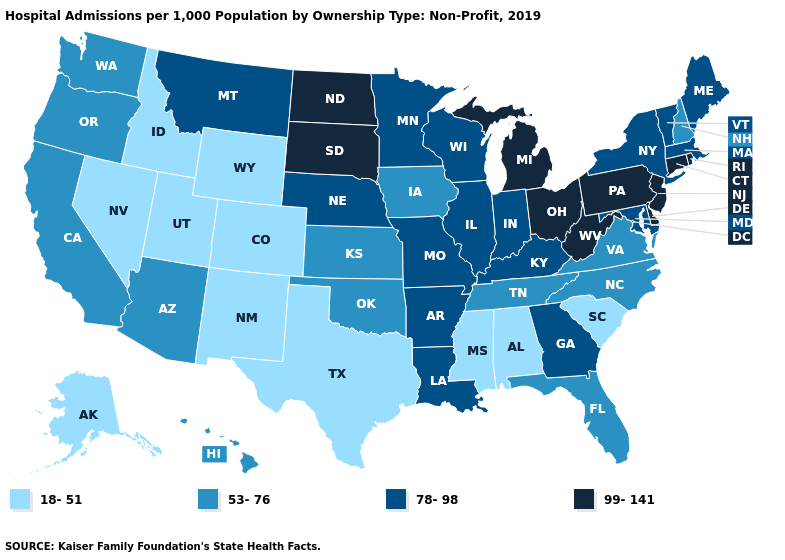What is the value of Iowa?
Quick response, please. 53-76. Name the states that have a value in the range 53-76?
Give a very brief answer. Arizona, California, Florida, Hawaii, Iowa, Kansas, New Hampshire, North Carolina, Oklahoma, Oregon, Tennessee, Virginia, Washington. What is the value of Delaware?
Give a very brief answer. 99-141. Among the states that border New Jersey , which have the lowest value?
Write a very short answer. New York. What is the highest value in the USA?
Concise answer only. 99-141. What is the highest value in the Northeast ?
Answer briefly. 99-141. Among the states that border Georgia , which have the lowest value?
Write a very short answer. Alabama, South Carolina. Does the first symbol in the legend represent the smallest category?
Quick response, please. Yes. What is the lowest value in states that border West Virginia?
Concise answer only. 53-76. Which states have the lowest value in the South?
Be succinct. Alabama, Mississippi, South Carolina, Texas. Name the states that have a value in the range 18-51?
Answer briefly. Alabama, Alaska, Colorado, Idaho, Mississippi, Nevada, New Mexico, South Carolina, Texas, Utah, Wyoming. What is the lowest value in the USA?
Concise answer only. 18-51. Does the first symbol in the legend represent the smallest category?
Concise answer only. Yes. Among the states that border Illinois , which have the highest value?
Write a very short answer. Indiana, Kentucky, Missouri, Wisconsin. Which states hav the highest value in the West?
Answer briefly. Montana. 